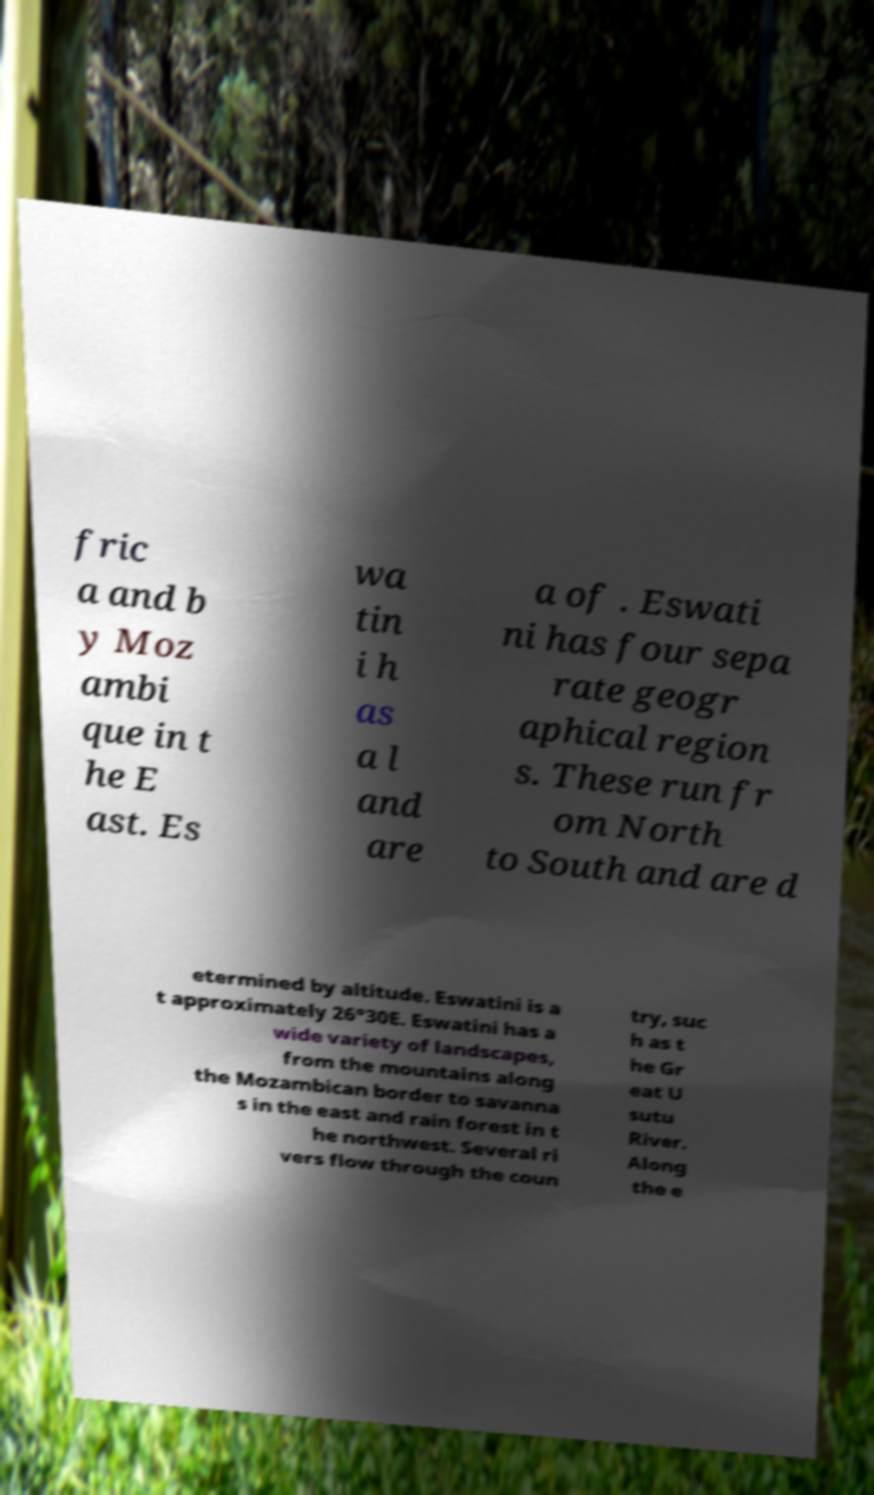Please read and relay the text visible in this image. What does it say? fric a and b y Moz ambi que in t he E ast. Es wa tin i h as a l and are a of . Eswati ni has four sepa rate geogr aphical region s. These run fr om North to South and are d etermined by altitude. Eswatini is a t approximately 26°30E. Eswatini has a wide variety of landscapes, from the mountains along the Mozambican border to savanna s in the east and rain forest in t he northwest. Several ri vers flow through the coun try, suc h as t he Gr eat U sutu River. Along the e 